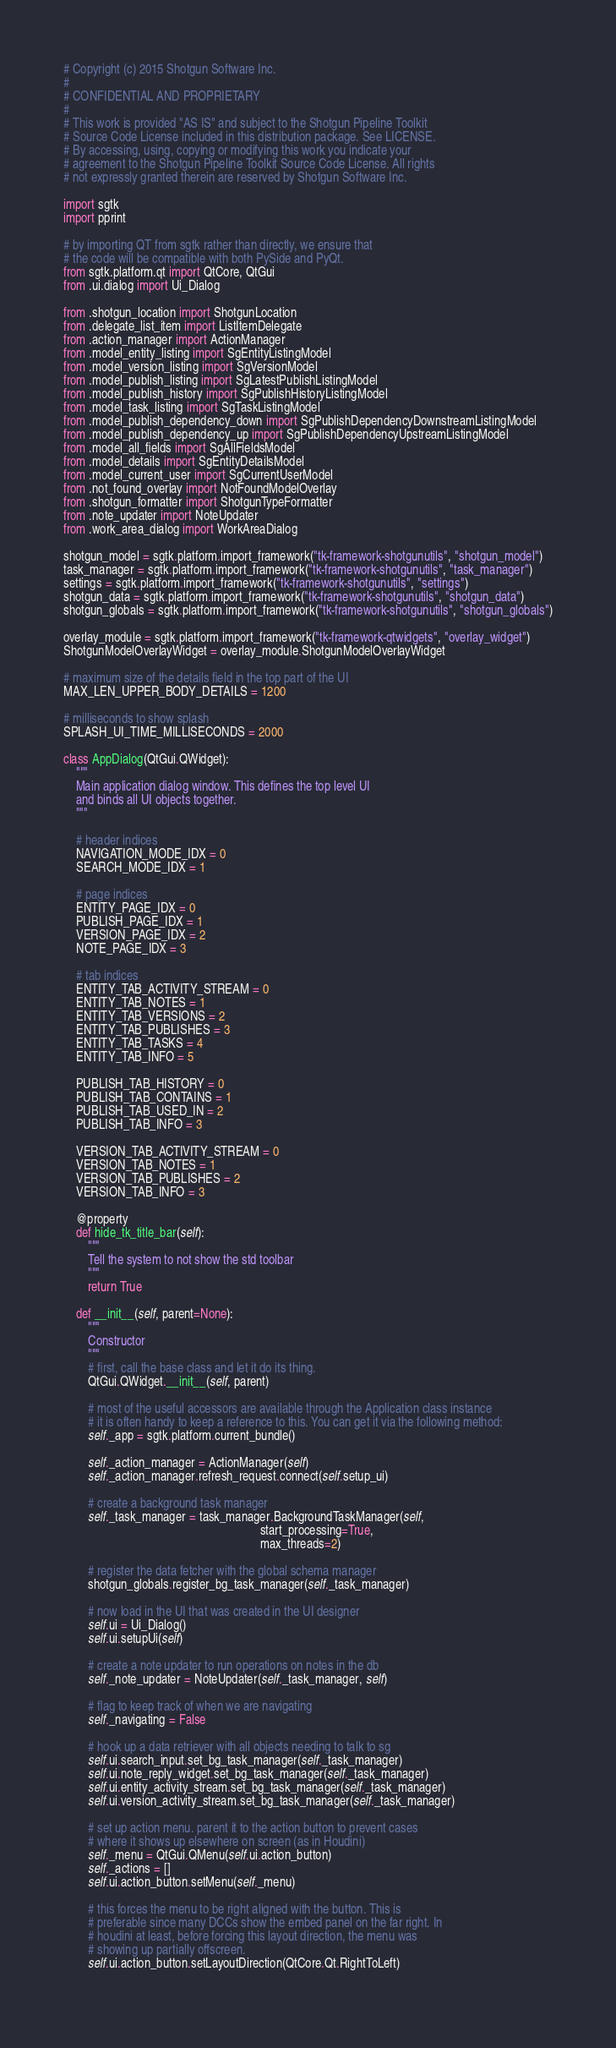<code> <loc_0><loc_0><loc_500><loc_500><_Python_># Copyright (c) 2015 Shotgun Software Inc.
# 
# CONFIDENTIAL AND PROPRIETARY
# 
# This work is provided "AS IS" and subject to the Shotgun Pipeline Toolkit 
# Source Code License included in this distribution package. See LICENSE.
# By accessing, using, copying or modifying this work you indicate your 
# agreement to the Shotgun Pipeline Toolkit Source Code License. All rights 
# not expressly granted therein are reserved by Shotgun Software Inc.

import sgtk
import pprint

# by importing QT from sgtk rather than directly, we ensure that
# the code will be compatible with both PySide and PyQt.
from sgtk.platform.qt import QtCore, QtGui
from .ui.dialog import Ui_Dialog

from .shotgun_location import ShotgunLocation
from .delegate_list_item import ListItemDelegate
from .action_manager import ActionManager
from .model_entity_listing import SgEntityListingModel
from .model_version_listing import SgVersionModel
from .model_publish_listing import SgLatestPublishListingModel
from .model_publish_history import SgPublishHistoryListingModel
from .model_task_listing import SgTaskListingModel
from .model_publish_dependency_down import SgPublishDependencyDownstreamListingModel
from .model_publish_dependency_up import SgPublishDependencyUpstreamListingModel
from .model_all_fields import SgAllFieldsModel
from .model_details import SgEntityDetailsModel
from .model_current_user import SgCurrentUserModel
from .not_found_overlay import NotFoundModelOverlay
from .shotgun_formatter import ShotgunTypeFormatter
from .note_updater import NoteUpdater
from .work_area_dialog import WorkAreaDialog

shotgun_model = sgtk.platform.import_framework("tk-framework-shotgunutils", "shotgun_model")
task_manager = sgtk.platform.import_framework("tk-framework-shotgunutils", "task_manager")
settings = sgtk.platform.import_framework("tk-framework-shotgunutils", "settings")
shotgun_data = sgtk.platform.import_framework("tk-framework-shotgunutils", "shotgun_data")
shotgun_globals = sgtk.platform.import_framework("tk-framework-shotgunutils", "shotgun_globals")

overlay_module = sgtk.platform.import_framework("tk-framework-qtwidgets", "overlay_widget")
ShotgunModelOverlayWidget = overlay_module.ShotgunModelOverlayWidget

# maximum size of the details field in the top part of the UI
MAX_LEN_UPPER_BODY_DETAILS = 1200

# milliseconds to show splash
SPLASH_UI_TIME_MILLISECONDS = 2000

class AppDialog(QtGui.QWidget):
    """
    Main application dialog window. This defines the top level UI
    and binds all UI objects together.
    """

    # header indices
    NAVIGATION_MODE_IDX = 0
    SEARCH_MODE_IDX = 1
    
    # page indices
    ENTITY_PAGE_IDX = 0
    PUBLISH_PAGE_IDX = 1
    VERSION_PAGE_IDX = 2
    NOTE_PAGE_IDX = 3
    
    # tab indices
    ENTITY_TAB_ACTIVITY_STREAM = 0
    ENTITY_TAB_NOTES = 1
    ENTITY_TAB_VERSIONS = 2
    ENTITY_TAB_PUBLISHES = 3
    ENTITY_TAB_TASKS = 4
    ENTITY_TAB_INFO = 5
    
    PUBLISH_TAB_HISTORY = 0
    PUBLISH_TAB_CONTAINS = 1
    PUBLISH_TAB_USED_IN = 2
    PUBLISH_TAB_INFO = 3
    
    VERSION_TAB_ACTIVITY_STREAM = 0
    VERSION_TAB_NOTES = 1 
    VERSION_TAB_PUBLISHES = 2
    VERSION_TAB_INFO = 3
    
    @property
    def hide_tk_title_bar(self):
        """
        Tell the system to not show the std toolbar
        """
        return True
    
    def __init__(self, parent=None):
        """
        Constructor
        """
        # first, call the base class and let it do its thing.
        QtGui.QWidget.__init__(self, parent)
        
        # most of the useful accessors are available through the Application class instance
        # it is often handy to keep a reference to this. You can get it via the following method:
        self._app = sgtk.platform.current_bundle()
        
        self._action_manager = ActionManager(self)
        self._action_manager.refresh_request.connect(self.setup_ui)

        # create a background task manager
        self._task_manager = task_manager.BackgroundTaskManager(self, 
                                                                start_processing=True, 
                                                                max_threads=2)

        # register the data fetcher with the global schema manager
        shotgun_globals.register_bg_task_manager(self._task_manager)
                
        # now load in the UI that was created in the UI designer
        self.ui = Ui_Dialog() 
        self.ui.setupUi(self)

        # create a note updater to run operations on notes in the db
        self._note_updater = NoteUpdater(self._task_manager, self)

        # flag to keep track of when we are navigating
        self._navigating = False

        # hook up a data retriever with all objects needing to talk to sg
        self.ui.search_input.set_bg_task_manager(self._task_manager)
        self.ui.note_reply_widget.set_bg_task_manager(self._task_manager)    
        self.ui.entity_activity_stream.set_bg_task_manager(self._task_manager)
        self.ui.version_activity_stream.set_bg_task_manager(self._task_manager)

        # set up action menu. parent it to the action button to prevent cases
        # where it shows up elsewhere on screen (as in Houdini)
        self._menu = QtGui.QMenu(self.ui.action_button)
        self._actions = []
        self.ui.action_button.setMenu(self._menu)        

        # this forces the menu to be right aligned with the button. This is
        # preferable since many DCCs show the embed panel on the far right. In
        # houdini at least, before forcing this layout direction, the menu was
        # showing up partially offscreen.
        self.ui.action_button.setLayoutDirection(QtCore.Qt.RightToLeft)
        </code> 